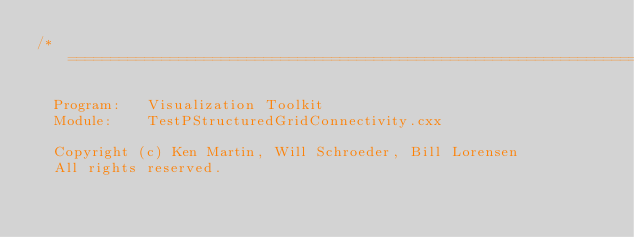<code> <loc_0><loc_0><loc_500><loc_500><_C++_>/*=========================================================================

  Program:   Visualization Toolkit
  Module:    TestPStructuredGridConnectivity.cxx

  Copyright (c) Ken Martin, Will Schroeder, Bill Lorensen
  All rights reserved.</code> 